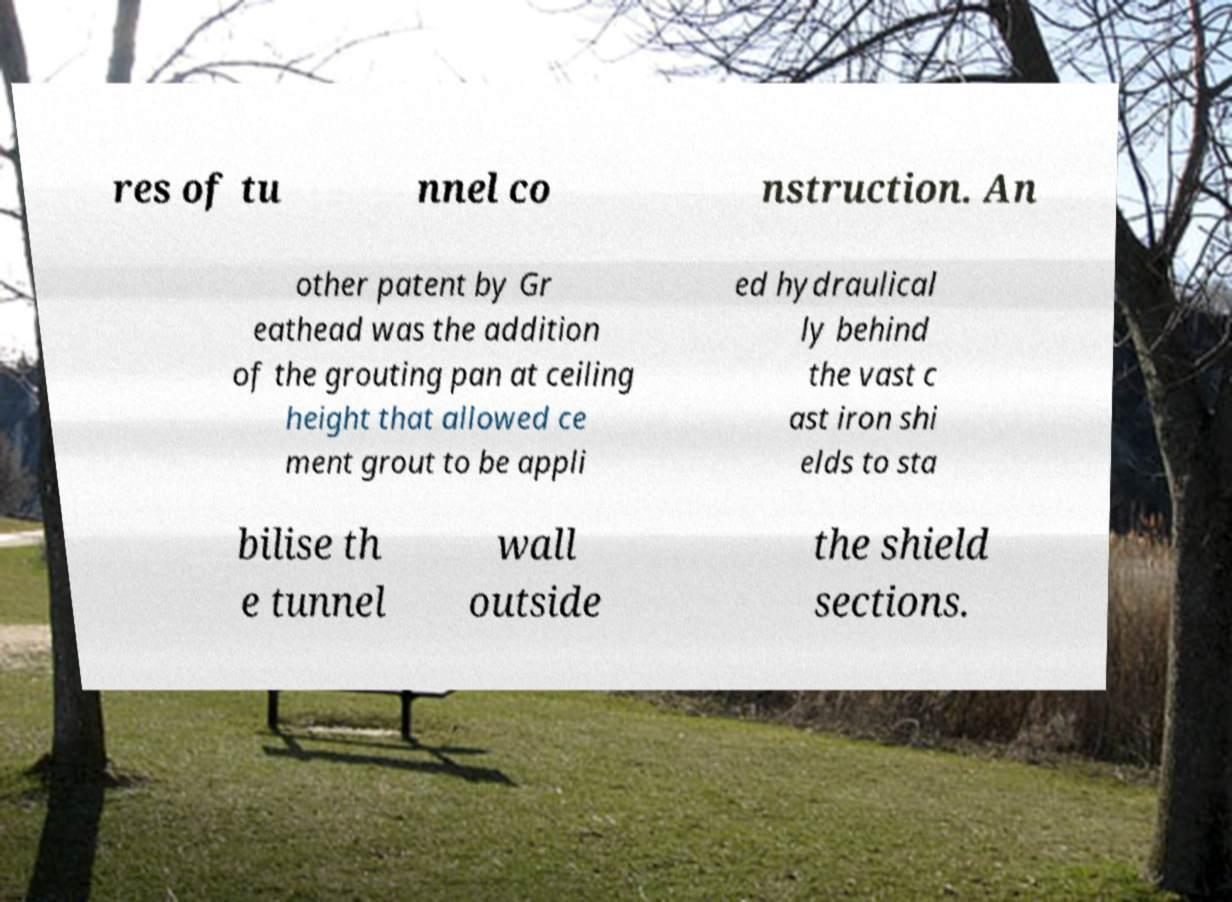For documentation purposes, I need the text within this image transcribed. Could you provide that? res of tu nnel co nstruction. An other patent by Gr eathead was the addition of the grouting pan at ceiling height that allowed ce ment grout to be appli ed hydraulical ly behind the vast c ast iron shi elds to sta bilise th e tunnel wall outside the shield sections. 